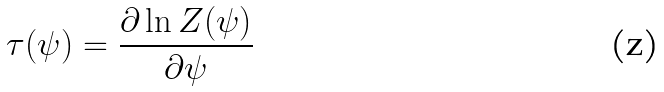Convert formula to latex. <formula><loc_0><loc_0><loc_500><loc_500>\tau ( \psi ) = \frac { \partial \ln Z ( \psi ) } { \partial \psi }</formula> 